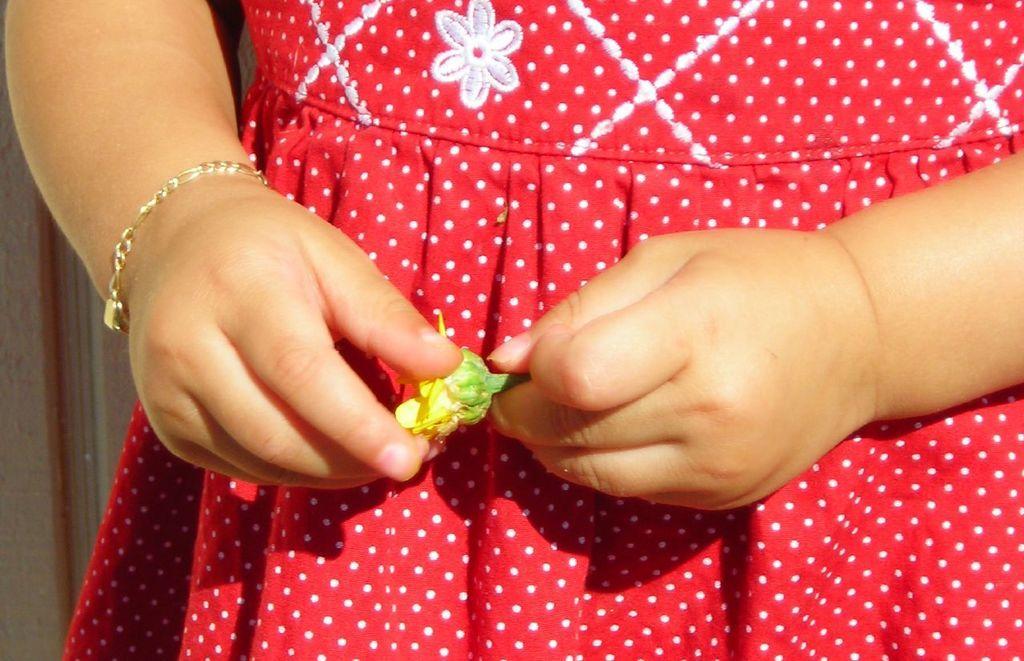Could you give a brief overview of what you see in this image? In this image I can see hands of a person is holding yellow and green colour thing. I can also see that person is wearing bracelet and red dress. 